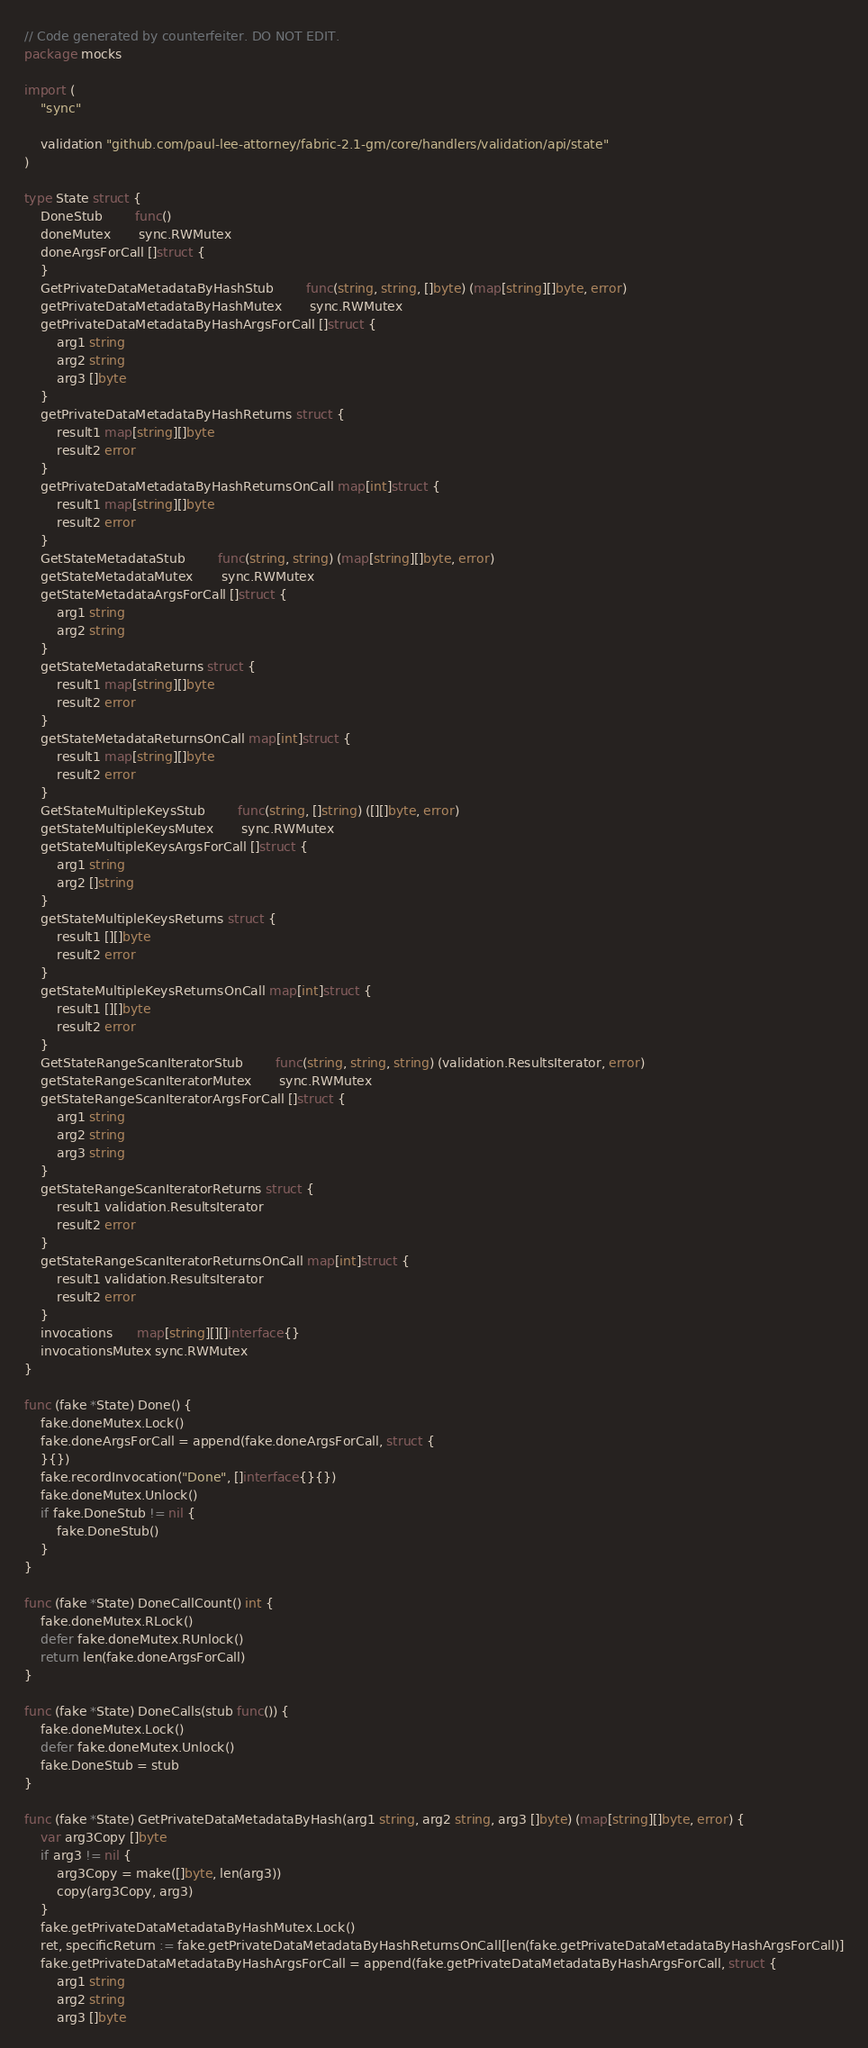<code> <loc_0><loc_0><loc_500><loc_500><_Go_>// Code generated by counterfeiter. DO NOT EDIT.
package mocks

import (
	"sync"

	validation "github.com/paul-lee-attorney/fabric-2.1-gm/core/handlers/validation/api/state"
)

type State struct {
	DoneStub        func()
	doneMutex       sync.RWMutex
	doneArgsForCall []struct {
	}
	GetPrivateDataMetadataByHashStub        func(string, string, []byte) (map[string][]byte, error)
	getPrivateDataMetadataByHashMutex       sync.RWMutex
	getPrivateDataMetadataByHashArgsForCall []struct {
		arg1 string
		arg2 string
		arg3 []byte
	}
	getPrivateDataMetadataByHashReturns struct {
		result1 map[string][]byte
		result2 error
	}
	getPrivateDataMetadataByHashReturnsOnCall map[int]struct {
		result1 map[string][]byte
		result2 error
	}
	GetStateMetadataStub        func(string, string) (map[string][]byte, error)
	getStateMetadataMutex       sync.RWMutex
	getStateMetadataArgsForCall []struct {
		arg1 string
		arg2 string
	}
	getStateMetadataReturns struct {
		result1 map[string][]byte
		result2 error
	}
	getStateMetadataReturnsOnCall map[int]struct {
		result1 map[string][]byte
		result2 error
	}
	GetStateMultipleKeysStub        func(string, []string) ([][]byte, error)
	getStateMultipleKeysMutex       sync.RWMutex
	getStateMultipleKeysArgsForCall []struct {
		arg1 string
		arg2 []string
	}
	getStateMultipleKeysReturns struct {
		result1 [][]byte
		result2 error
	}
	getStateMultipleKeysReturnsOnCall map[int]struct {
		result1 [][]byte
		result2 error
	}
	GetStateRangeScanIteratorStub        func(string, string, string) (validation.ResultsIterator, error)
	getStateRangeScanIteratorMutex       sync.RWMutex
	getStateRangeScanIteratorArgsForCall []struct {
		arg1 string
		arg2 string
		arg3 string
	}
	getStateRangeScanIteratorReturns struct {
		result1 validation.ResultsIterator
		result2 error
	}
	getStateRangeScanIteratorReturnsOnCall map[int]struct {
		result1 validation.ResultsIterator
		result2 error
	}
	invocations      map[string][][]interface{}
	invocationsMutex sync.RWMutex
}

func (fake *State) Done() {
	fake.doneMutex.Lock()
	fake.doneArgsForCall = append(fake.doneArgsForCall, struct {
	}{})
	fake.recordInvocation("Done", []interface{}{})
	fake.doneMutex.Unlock()
	if fake.DoneStub != nil {
		fake.DoneStub()
	}
}

func (fake *State) DoneCallCount() int {
	fake.doneMutex.RLock()
	defer fake.doneMutex.RUnlock()
	return len(fake.doneArgsForCall)
}

func (fake *State) DoneCalls(stub func()) {
	fake.doneMutex.Lock()
	defer fake.doneMutex.Unlock()
	fake.DoneStub = stub
}

func (fake *State) GetPrivateDataMetadataByHash(arg1 string, arg2 string, arg3 []byte) (map[string][]byte, error) {
	var arg3Copy []byte
	if arg3 != nil {
		arg3Copy = make([]byte, len(arg3))
		copy(arg3Copy, arg3)
	}
	fake.getPrivateDataMetadataByHashMutex.Lock()
	ret, specificReturn := fake.getPrivateDataMetadataByHashReturnsOnCall[len(fake.getPrivateDataMetadataByHashArgsForCall)]
	fake.getPrivateDataMetadataByHashArgsForCall = append(fake.getPrivateDataMetadataByHashArgsForCall, struct {
		arg1 string
		arg2 string
		arg3 []byte</code> 